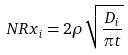Convert formula to latex. <formula><loc_0><loc_0><loc_500><loc_500>N R x _ { i } = 2 \rho \sqrt { \frac { D _ { i } } { \pi t } }</formula> 